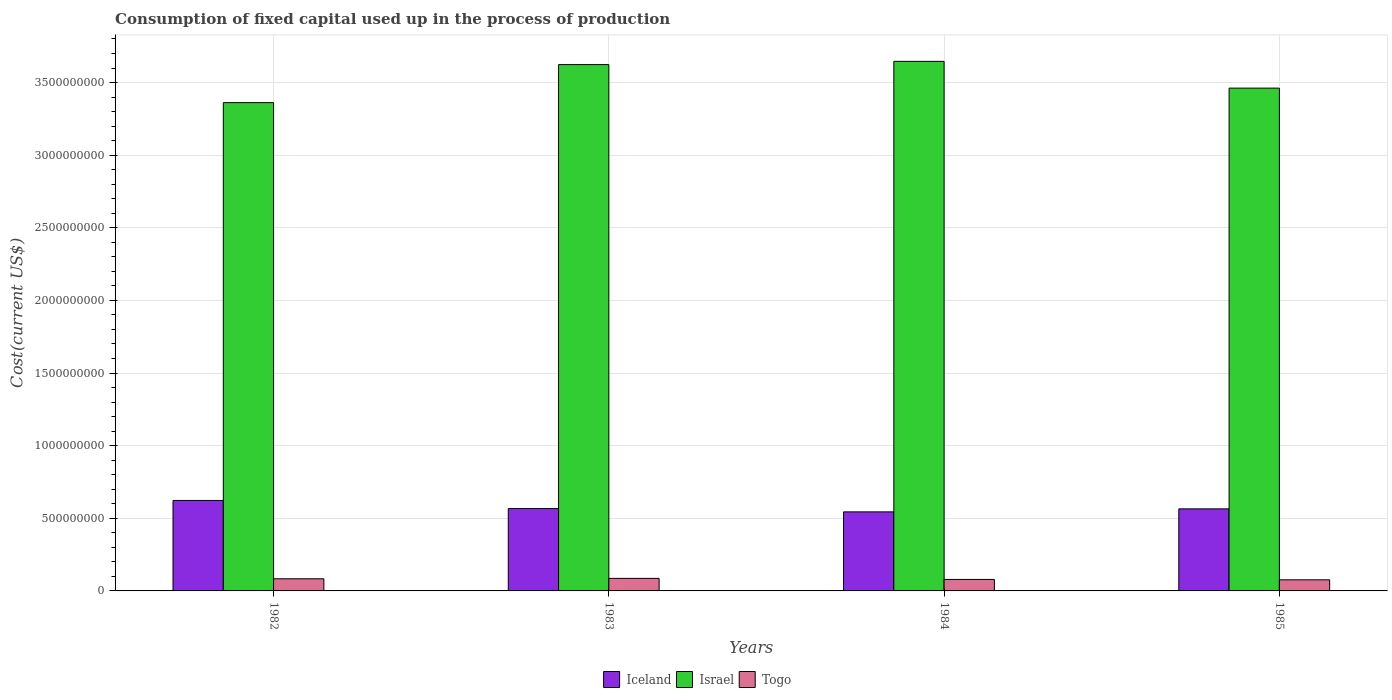How many different coloured bars are there?
Keep it short and to the point. 3. How many groups of bars are there?
Keep it short and to the point. 4. Are the number of bars per tick equal to the number of legend labels?
Your answer should be very brief. Yes. Are the number of bars on each tick of the X-axis equal?
Make the answer very short. Yes. In how many cases, is the number of bars for a given year not equal to the number of legend labels?
Your answer should be very brief. 0. What is the amount consumed in the process of production in Togo in 1984?
Provide a succinct answer. 7.91e+07. Across all years, what is the maximum amount consumed in the process of production in Israel?
Offer a terse response. 3.65e+09. Across all years, what is the minimum amount consumed in the process of production in Iceland?
Provide a succinct answer. 5.44e+08. What is the total amount consumed in the process of production in Iceland in the graph?
Give a very brief answer. 2.30e+09. What is the difference between the amount consumed in the process of production in Iceland in 1982 and that in 1985?
Offer a very short reply. 5.78e+07. What is the difference between the amount consumed in the process of production in Iceland in 1982 and the amount consumed in the process of production in Israel in 1983?
Provide a short and direct response. -3.00e+09. What is the average amount consumed in the process of production in Togo per year?
Provide a succinct answer. 8.14e+07. In the year 1982, what is the difference between the amount consumed in the process of production in Israel and amount consumed in the process of production in Iceland?
Your answer should be compact. 2.74e+09. What is the ratio of the amount consumed in the process of production in Israel in 1984 to that in 1985?
Your answer should be very brief. 1.05. Is the amount consumed in the process of production in Israel in 1982 less than that in 1984?
Your answer should be compact. Yes. What is the difference between the highest and the second highest amount consumed in the process of production in Iceland?
Your answer should be compact. 5.57e+07. What is the difference between the highest and the lowest amount consumed in the process of production in Togo?
Provide a short and direct response. 1.00e+07. Is the sum of the amount consumed in the process of production in Togo in 1983 and 1984 greater than the maximum amount consumed in the process of production in Israel across all years?
Make the answer very short. No. What does the 1st bar from the left in 1984 represents?
Offer a terse response. Iceland. What does the 1st bar from the right in 1982 represents?
Provide a short and direct response. Togo. Is it the case that in every year, the sum of the amount consumed in the process of production in Togo and amount consumed in the process of production in Israel is greater than the amount consumed in the process of production in Iceland?
Ensure brevity in your answer.  Yes. How many bars are there?
Provide a succinct answer. 12. Where does the legend appear in the graph?
Provide a succinct answer. Bottom center. What is the title of the graph?
Make the answer very short. Consumption of fixed capital used up in the process of production. Does "Indonesia" appear as one of the legend labels in the graph?
Provide a short and direct response. No. What is the label or title of the X-axis?
Give a very brief answer. Years. What is the label or title of the Y-axis?
Your answer should be very brief. Cost(current US$). What is the Cost(current US$) in Iceland in 1982?
Your answer should be compact. 6.23e+08. What is the Cost(current US$) in Israel in 1982?
Make the answer very short. 3.36e+09. What is the Cost(current US$) in Togo in 1982?
Your response must be concise. 8.36e+07. What is the Cost(current US$) of Iceland in 1983?
Make the answer very short. 5.67e+08. What is the Cost(current US$) of Israel in 1983?
Offer a very short reply. 3.62e+09. What is the Cost(current US$) of Togo in 1983?
Keep it short and to the point. 8.65e+07. What is the Cost(current US$) of Iceland in 1984?
Offer a very short reply. 5.44e+08. What is the Cost(current US$) in Israel in 1984?
Your answer should be compact. 3.65e+09. What is the Cost(current US$) in Togo in 1984?
Your answer should be compact. 7.91e+07. What is the Cost(current US$) of Iceland in 1985?
Give a very brief answer. 5.65e+08. What is the Cost(current US$) of Israel in 1985?
Keep it short and to the point. 3.46e+09. What is the Cost(current US$) of Togo in 1985?
Make the answer very short. 7.64e+07. Across all years, what is the maximum Cost(current US$) in Iceland?
Provide a short and direct response. 6.23e+08. Across all years, what is the maximum Cost(current US$) of Israel?
Your response must be concise. 3.65e+09. Across all years, what is the maximum Cost(current US$) of Togo?
Give a very brief answer. 8.65e+07. Across all years, what is the minimum Cost(current US$) in Iceland?
Offer a terse response. 5.44e+08. Across all years, what is the minimum Cost(current US$) in Israel?
Provide a succinct answer. 3.36e+09. Across all years, what is the minimum Cost(current US$) of Togo?
Ensure brevity in your answer.  7.64e+07. What is the total Cost(current US$) in Iceland in the graph?
Provide a succinct answer. 2.30e+09. What is the total Cost(current US$) of Israel in the graph?
Ensure brevity in your answer.  1.41e+1. What is the total Cost(current US$) in Togo in the graph?
Your answer should be very brief. 3.26e+08. What is the difference between the Cost(current US$) of Iceland in 1982 and that in 1983?
Offer a very short reply. 5.57e+07. What is the difference between the Cost(current US$) in Israel in 1982 and that in 1983?
Offer a terse response. -2.62e+08. What is the difference between the Cost(current US$) in Togo in 1982 and that in 1983?
Offer a terse response. -2.92e+06. What is the difference between the Cost(current US$) in Iceland in 1982 and that in 1984?
Your response must be concise. 7.86e+07. What is the difference between the Cost(current US$) of Israel in 1982 and that in 1984?
Your response must be concise. -2.84e+08. What is the difference between the Cost(current US$) of Togo in 1982 and that in 1984?
Provide a short and direct response. 4.48e+06. What is the difference between the Cost(current US$) of Iceland in 1982 and that in 1985?
Provide a succinct answer. 5.78e+07. What is the difference between the Cost(current US$) of Israel in 1982 and that in 1985?
Your answer should be compact. -9.99e+07. What is the difference between the Cost(current US$) of Togo in 1982 and that in 1985?
Offer a terse response. 7.13e+06. What is the difference between the Cost(current US$) of Iceland in 1983 and that in 1984?
Your answer should be very brief. 2.29e+07. What is the difference between the Cost(current US$) of Israel in 1983 and that in 1984?
Offer a terse response. -2.23e+07. What is the difference between the Cost(current US$) of Togo in 1983 and that in 1984?
Give a very brief answer. 7.40e+06. What is the difference between the Cost(current US$) in Iceland in 1983 and that in 1985?
Offer a terse response. 2.11e+06. What is the difference between the Cost(current US$) in Israel in 1983 and that in 1985?
Keep it short and to the point. 1.62e+08. What is the difference between the Cost(current US$) in Togo in 1983 and that in 1985?
Give a very brief answer. 1.00e+07. What is the difference between the Cost(current US$) in Iceland in 1984 and that in 1985?
Offer a very short reply. -2.07e+07. What is the difference between the Cost(current US$) in Israel in 1984 and that in 1985?
Your answer should be compact. 1.84e+08. What is the difference between the Cost(current US$) in Togo in 1984 and that in 1985?
Your response must be concise. 2.64e+06. What is the difference between the Cost(current US$) in Iceland in 1982 and the Cost(current US$) in Israel in 1983?
Provide a short and direct response. -3.00e+09. What is the difference between the Cost(current US$) of Iceland in 1982 and the Cost(current US$) of Togo in 1983?
Your answer should be compact. 5.36e+08. What is the difference between the Cost(current US$) of Israel in 1982 and the Cost(current US$) of Togo in 1983?
Provide a short and direct response. 3.28e+09. What is the difference between the Cost(current US$) of Iceland in 1982 and the Cost(current US$) of Israel in 1984?
Give a very brief answer. -3.02e+09. What is the difference between the Cost(current US$) of Iceland in 1982 and the Cost(current US$) of Togo in 1984?
Make the answer very short. 5.44e+08. What is the difference between the Cost(current US$) in Israel in 1982 and the Cost(current US$) in Togo in 1984?
Give a very brief answer. 3.28e+09. What is the difference between the Cost(current US$) in Iceland in 1982 and the Cost(current US$) in Israel in 1985?
Your answer should be very brief. -2.84e+09. What is the difference between the Cost(current US$) in Iceland in 1982 and the Cost(current US$) in Togo in 1985?
Provide a succinct answer. 5.46e+08. What is the difference between the Cost(current US$) in Israel in 1982 and the Cost(current US$) in Togo in 1985?
Offer a terse response. 3.29e+09. What is the difference between the Cost(current US$) in Iceland in 1983 and the Cost(current US$) in Israel in 1984?
Keep it short and to the point. -3.08e+09. What is the difference between the Cost(current US$) in Iceland in 1983 and the Cost(current US$) in Togo in 1984?
Give a very brief answer. 4.88e+08. What is the difference between the Cost(current US$) of Israel in 1983 and the Cost(current US$) of Togo in 1984?
Keep it short and to the point. 3.54e+09. What is the difference between the Cost(current US$) of Iceland in 1983 and the Cost(current US$) of Israel in 1985?
Make the answer very short. -2.89e+09. What is the difference between the Cost(current US$) in Iceland in 1983 and the Cost(current US$) in Togo in 1985?
Provide a short and direct response. 4.91e+08. What is the difference between the Cost(current US$) of Israel in 1983 and the Cost(current US$) of Togo in 1985?
Your answer should be compact. 3.55e+09. What is the difference between the Cost(current US$) in Iceland in 1984 and the Cost(current US$) in Israel in 1985?
Your response must be concise. -2.92e+09. What is the difference between the Cost(current US$) of Iceland in 1984 and the Cost(current US$) of Togo in 1985?
Make the answer very short. 4.68e+08. What is the difference between the Cost(current US$) of Israel in 1984 and the Cost(current US$) of Togo in 1985?
Provide a succinct answer. 3.57e+09. What is the average Cost(current US$) in Iceland per year?
Offer a terse response. 5.75e+08. What is the average Cost(current US$) in Israel per year?
Your answer should be very brief. 3.52e+09. What is the average Cost(current US$) in Togo per year?
Your response must be concise. 8.14e+07. In the year 1982, what is the difference between the Cost(current US$) of Iceland and Cost(current US$) of Israel?
Your answer should be compact. -2.74e+09. In the year 1982, what is the difference between the Cost(current US$) of Iceland and Cost(current US$) of Togo?
Provide a short and direct response. 5.39e+08. In the year 1982, what is the difference between the Cost(current US$) of Israel and Cost(current US$) of Togo?
Your answer should be compact. 3.28e+09. In the year 1983, what is the difference between the Cost(current US$) of Iceland and Cost(current US$) of Israel?
Your response must be concise. -3.06e+09. In the year 1983, what is the difference between the Cost(current US$) in Iceland and Cost(current US$) in Togo?
Provide a short and direct response. 4.81e+08. In the year 1983, what is the difference between the Cost(current US$) in Israel and Cost(current US$) in Togo?
Your response must be concise. 3.54e+09. In the year 1984, what is the difference between the Cost(current US$) in Iceland and Cost(current US$) in Israel?
Offer a terse response. -3.10e+09. In the year 1984, what is the difference between the Cost(current US$) in Iceland and Cost(current US$) in Togo?
Offer a terse response. 4.65e+08. In the year 1984, what is the difference between the Cost(current US$) in Israel and Cost(current US$) in Togo?
Your answer should be very brief. 3.57e+09. In the year 1985, what is the difference between the Cost(current US$) of Iceland and Cost(current US$) of Israel?
Your answer should be very brief. -2.90e+09. In the year 1985, what is the difference between the Cost(current US$) in Iceland and Cost(current US$) in Togo?
Provide a short and direct response. 4.89e+08. In the year 1985, what is the difference between the Cost(current US$) of Israel and Cost(current US$) of Togo?
Provide a succinct answer. 3.39e+09. What is the ratio of the Cost(current US$) of Iceland in 1982 to that in 1983?
Ensure brevity in your answer.  1.1. What is the ratio of the Cost(current US$) in Israel in 1982 to that in 1983?
Make the answer very short. 0.93. What is the ratio of the Cost(current US$) in Togo in 1982 to that in 1983?
Provide a short and direct response. 0.97. What is the ratio of the Cost(current US$) in Iceland in 1982 to that in 1984?
Ensure brevity in your answer.  1.14. What is the ratio of the Cost(current US$) of Israel in 1982 to that in 1984?
Offer a very short reply. 0.92. What is the ratio of the Cost(current US$) in Togo in 1982 to that in 1984?
Give a very brief answer. 1.06. What is the ratio of the Cost(current US$) of Iceland in 1982 to that in 1985?
Make the answer very short. 1.1. What is the ratio of the Cost(current US$) in Israel in 1982 to that in 1985?
Make the answer very short. 0.97. What is the ratio of the Cost(current US$) in Togo in 1982 to that in 1985?
Offer a very short reply. 1.09. What is the ratio of the Cost(current US$) in Iceland in 1983 to that in 1984?
Ensure brevity in your answer.  1.04. What is the ratio of the Cost(current US$) in Israel in 1983 to that in 1984?
Your answer should be very brief. 0.99. What is the ratio of the Cost(current US$) in Togo in 1983 to that in 1984?
Provide a succinct answer. 1.09. What is the ratio of the Cost(current US$) in Israel in 1983 to that in 1985?
Provide a succinct answer. 1.05. What is the ratio of the Cost(current US$) of Togo in 1983 to that in 1985?
Provide a succinct answer. 1.13. What is the ratio of the Cost(current US$) of Iceland in 1984 to that in 1985?
Offer a very short reply. 0.96. What is the ratio of the Cost(current US$) of Israel in 1984 to that in 1985?
Offer a terse response. 1.05. What is the ratio of the Cost(current US$) of Togo in 1984 to that in 1985?
Your answer should be very brief. 1.03. What is the difference between the highest and the second highest Cost(current US$) of Iceland?
Offer a terse response. 5.57e+07. What is the difference between the highest and the second highest Cost(current US$) of Israel?
Give a very brief answer. 2.23e+07. What is the difference between the highest and the second highest Cost(current US$) of Togo?
Make the answer very short. 2.92e+06. What is the difference between the highest and the lowest Cost(current US$) of Iceland?
Offer a very short reply. 7.86e+07. What is the difference between the highest and the lowest Cost(current US$) of Israel?
Ensure brevity in your answer.  2.84e+08. What is the difference between the highest and the lowest Cost(current US$) of Togo?
Offer a very short reply. 1.00e+07. 